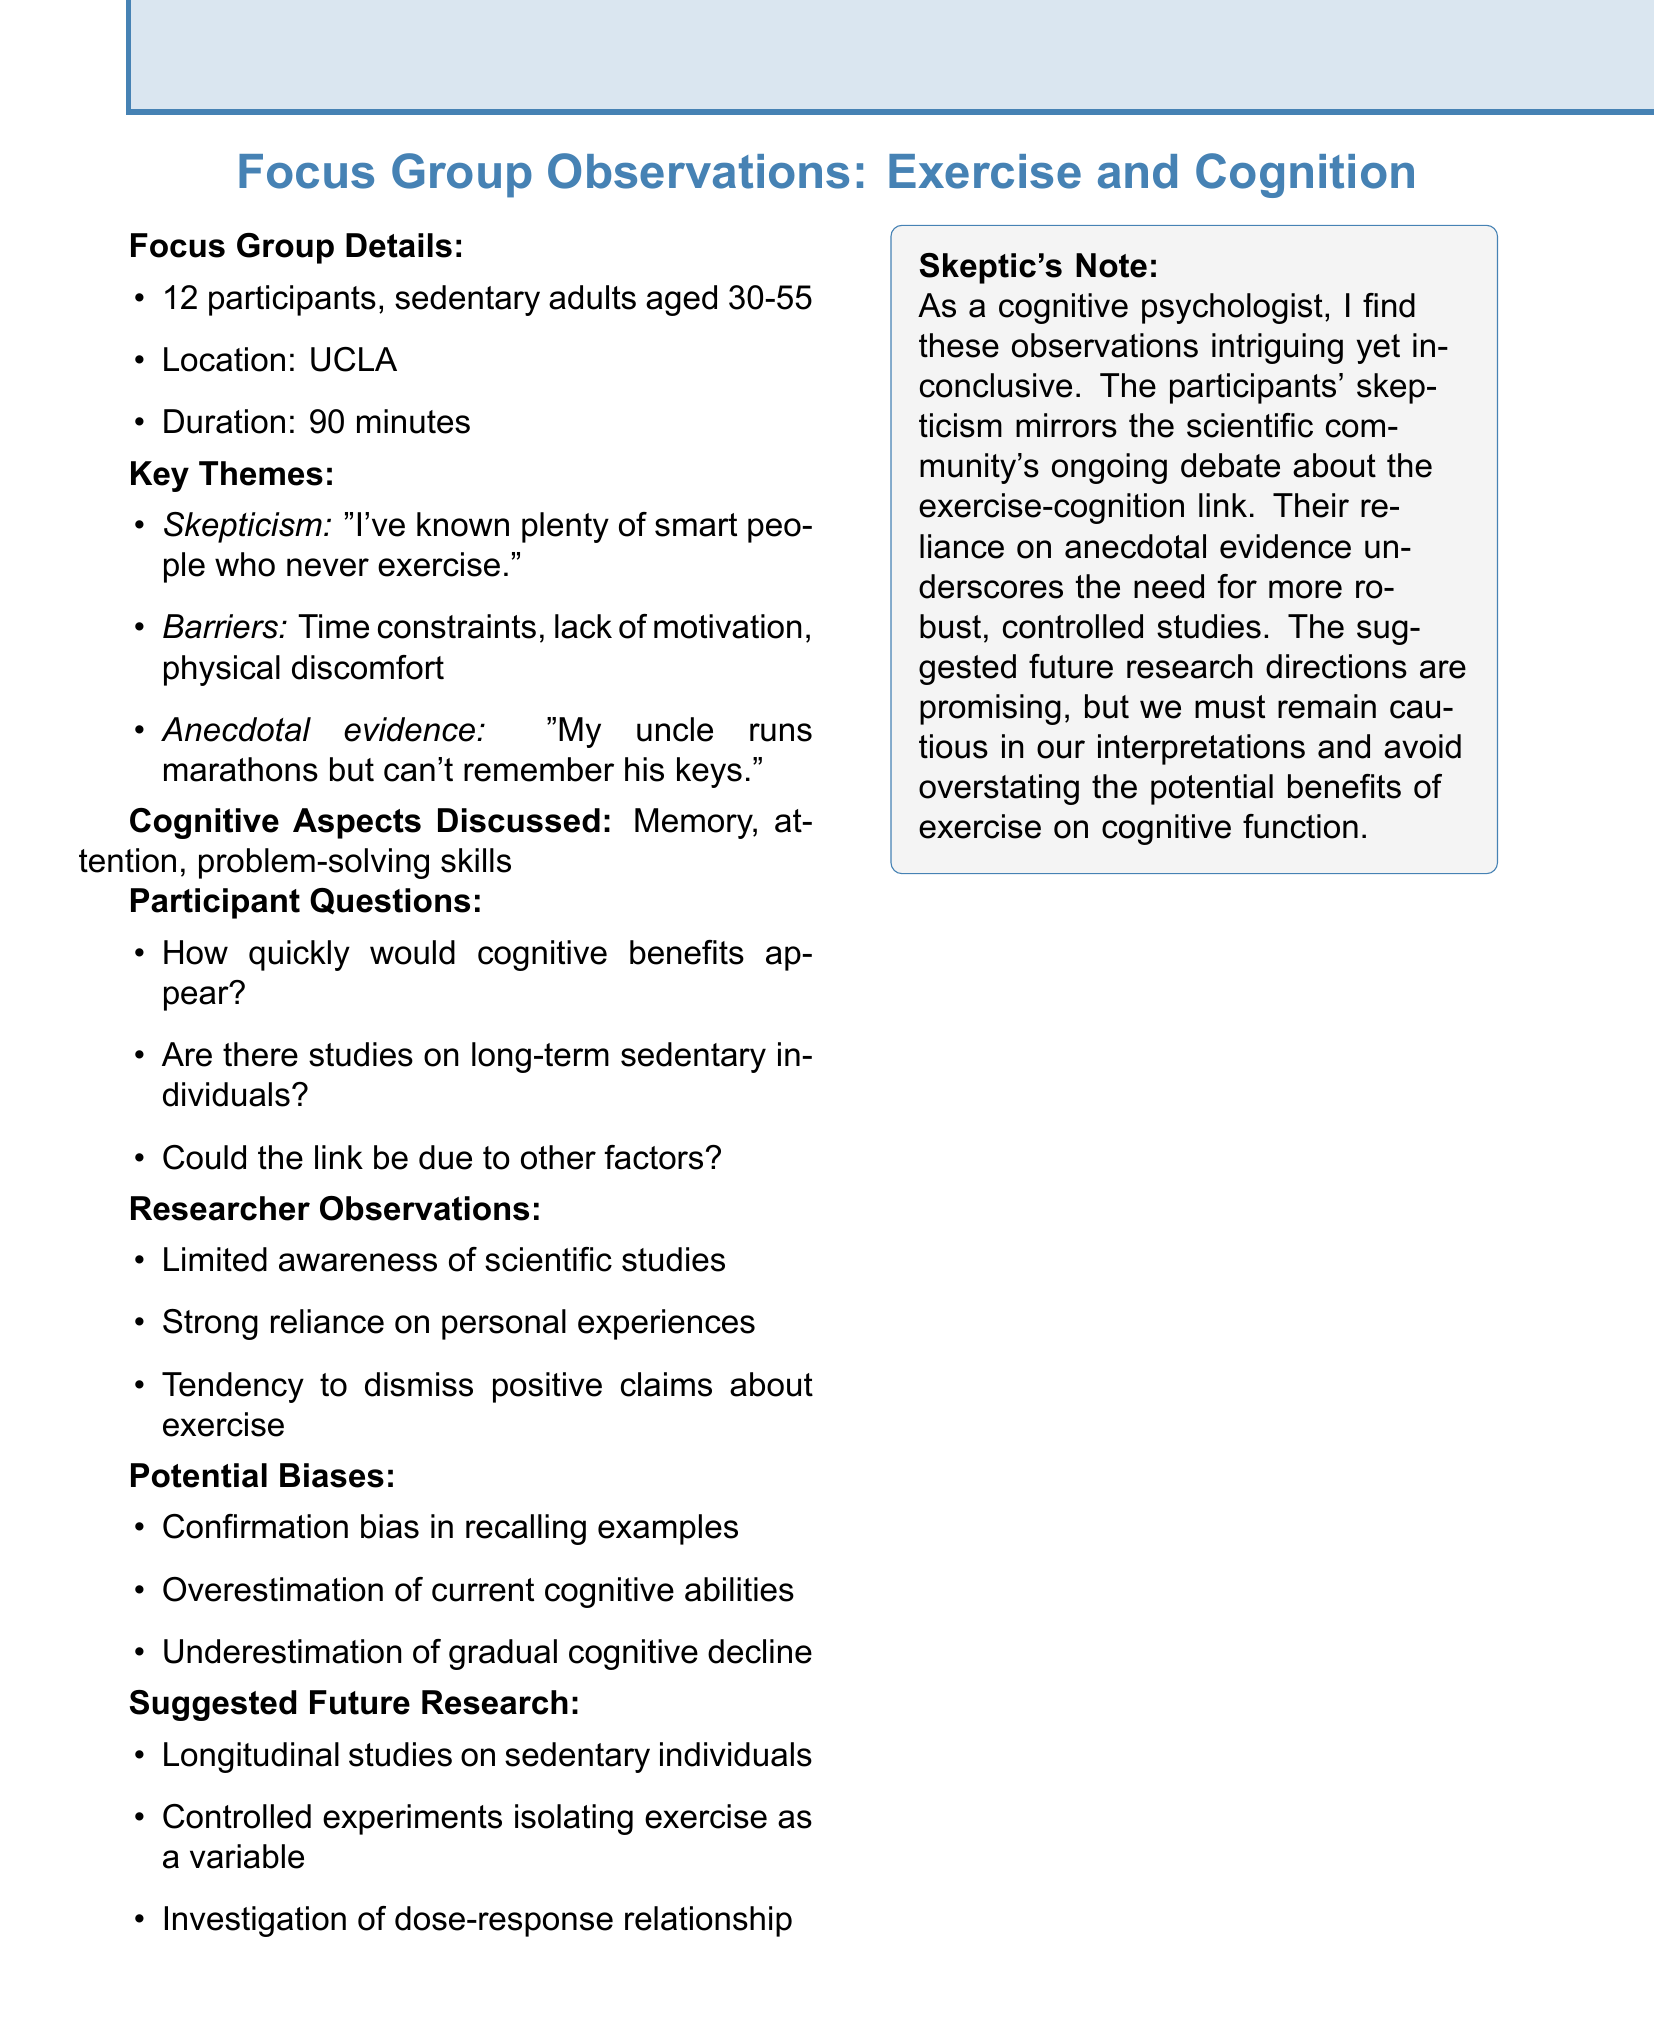What is the age range of participants? The age range of participants is specified as sedentary adults aged 30-55.
Answer: 30-55 How many participants were in the focus group? The document states that there were a total of 12 participants in the focus group.
Answer: 12 What is one perceived barrier to exercise mentioned? The document lists several barriers, one of which is time constraints.
Answer: Time constraints What cognitive aspects were discussed by the participants? The document outlines three cognitive aspects discussed: memory, attention, and problem-solving skills.
Answer: Memory, attention, problem-solving skills What is a quote expressing skepticism about the exercise-cognition link? The document includes a quote stating, "Seems like another health fad to me." which reflects skepticism.
Answer: Seems like another health fad to me What is suggested future research focus? The document suggests several future research directions, including longitudinal studies on sedentary individuals.
Answer: Longitudinal studies on sedentary individuals What did the participants show limited awareness of? The researcher observations note that participants showed limited awareness of scientific studies.
Answer: Scientific studies What type of bias might participants have regarding their cognitive abilities? The document mentions overestimation of current cognitive abilities as a potential bias.
Answer: Overestimation of current cognitive abilities How long did the focus group discussion last? The document states that the duration of the focus group discussion was 90 minutes.
Answer: 90 minutes 